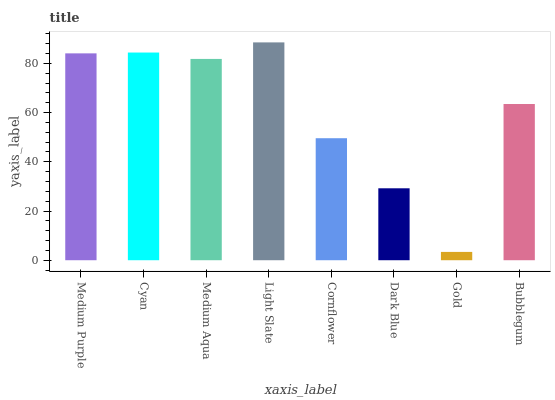Is Gold the minimum?
Answer yes or no. Yes. Is Light Slate the maximum?
Answer yes or no. Yes. Is Cyan the minimum?
Answer yes or no. No. Is Cyan the maximum?
Answer yes or no. No. Is Cyan greater than Medium Purple?
Answer yes or no. Yes. Is Medium Purple less than Cyan?
Answer yes or no. Yes. Is Medium Purple greater than Cyan?
Answer yes or no. No. Is Cyan less than Medium Purple?
Answer yes or no. No. Is Medium Aqua the high median?
Answer yes or no. Yes. Is Bubblegum the low median?
Answer yes or no. Yes. Is Gold the high median?
Answer yes or no. No. Is Gold the low median?
Answer yes or no. No. 